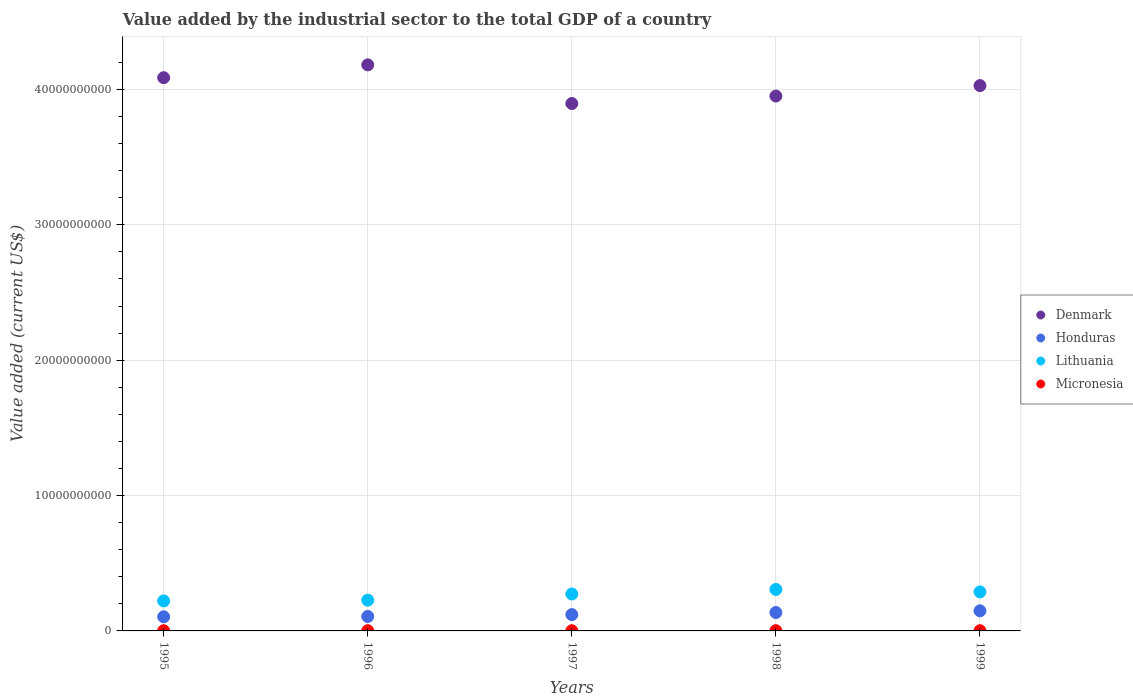How many different coloured dotlines are there?
Provide a short and direct response. 4. Is the number of dotlines equal to the number of legend labels?
Keep it short and to the point. Yes. What is the value added by the industrial sector to the total GDP in Micronesia in 1998?
Give a very brief answer. 1.81e+07. Across all years, what is the maximum value added by the industrial sector to the total GDP in Denmark?
Your response must be concise. 4.18e+1. Across all years, what is the minimum value added by the industrial sector to the total GDP in Honduras?
Your answer should be very brief. 1.04e+09. What is the total value added by the industrial sector to the total GDP in Micronesia in the graph?
Your answer should be compact. 8.26e+07. What is the difference between the value added by the industrial sector to the total GDP in Micronesia in 1996 and that in 1998?
Your response must be concise. -1.42e+06. What is the difference between the value added by the industrial sector to the total GDP in Denmark in 1997 and the value added by the industrial sector to the total GDP in Lithuania in 1999?
Ensure brevity in your answer.  3.61e+1. What is the average value added by the industrial sector to the total GDP in Micronesia per year?
Your answer should be compact. 1.65e+07. In the year 1995, what is the difference between the value added by the industrial sector to the total GDP in Honduras and value added by the industrial sector to the total GDP in Micronesia?
Ensure brevity in your answer.  1.03e+09. What is the ratio of the value added by the industrial sector to the total GDP in Micronesia in 1995 to that in 1997?
Your answer should be very brief. 1.05. What is the difference between the highest and the second highest value added by the industrial sector to the total GDP in Micronesia?
Keep it short and to the point. 5.22e+05. What is the difference between the highest and the lowest value added by the industrial sector to the total GDP in Denmark?
Your response must be concise. 2.86e+09. In how many years, is the value added by the industrial sector to the total GDP in Lithuania greater than the average value added by the industrial sector to the total GDP in Lithuania taken over all years?
Offer a terse response. 3. Is it the case that in every year, the sum of the value added by the industrial sector to the total GDP in Lithuania and value added by the industrial sector to the total GDP in Micronesia  is greater than the sum of value added by the industrial sector to the total GDP in Honduras and value added by the industrial sector to the total GDP in Denmark?
Provide a short and direct response. Yes. Does the value added by the industrial sector to the total GDP in Denmark monotonically increase over the years?
Offer a very short reply. No. Is the value added by the industrial sector to the total GDP in Denmark strictly greater than the value added by the industrial sector to the total GDP in Honduras over the years?
Offer a terse response. Yes. How many dotlines are there?
Provide a succinct answer. 4. What is the difference between two consecutive major ticks on the Y-axis?
Offer a very short reply. 1.00e+1. Does the graph contain grids?
Provide a short and direct response. Yes. What is the title of the graph?
Your response must be concise. Value added by the industrial sector to the total GDP of a country. What is the label or title of the Y-axis?
Offer a terse response. Value added (current US$). What is the Value added (current US$) of Denmark in 1995?
Your answer should be very brief. 4.09e+1. What is the Value added (current US$) of Honduras in 1995?
Provide a succinct answer. 1.04e+09. What is the Value added (current US$) of Lithuania in 1995?
Your answer should be very brief. 2.22e+09. What is the Value added (current US$) in Micronesia in 1995?
Ensure brevity in your answer.  1.55e+07. What is the Value added (current US$) of Denmark in 1996?
Provide a short and direct response. 4.18e+1. What is the Value added (current US$) in Honduras in 1996?
Ensure brevity in your answer.  1.07e+09. What is the Value added (current US$) of Lithuania in 1996?
Give a very brief answer. 2.27e+09. What is the Value added (current US$) in Micronesia in 1996?
Give a very brief answer. 1.67e+07. What is the Value added (current US$) in Denmark in 1997?
Offer a very short reply. 3.90e+1. What is the Value added (current US$) in Honduras in 1997?
Offer a very short reply. 1.21e+09. What is the Value added (current US$) of Lithuania in 1997?
Give a very brief answer. 2.73e+09. What is the Value added (current US$) of Micronesia in 1997?
Your response must be concise. 1.48e+07. What is the Value added (current US$) in Denmark in 1998?
Provide a short and direct response. 3.95e+1. What is the Value added (current US$) in Honduras in 1998?
Make the answer very short. 1.36e+09. What is the Value added (current US$) of Lithuania in 1998?
Provide a succinct answer. 3.06e+09. What is the Value added (current US$) in Micronesia in 1998?
Your answer should be very brief. 1.81e+07. What is the Value added (current US$) in Denmark in 1999?
Provide a succinct answer. 4.03e+1. What is the Value added (current US$) in Honduras in 1999?
Offer a very short reply. 1.49e+09. What is the Value added (current US$) in Lithuania in 1999?
Provide a short and direct response. 2.88e+09. What is the Value added (current US$) of Micronesia in 1999?
Provide a succinct answer. 1.76e+07. Across all years, what is the maximum Value added (current US$) of Denmark?
Ensure brevity in your answer.  4.18e+1. Across all years, what is the maximum Value added (current US$) of Honduras?
Offer a very short reply. 1.49e+09. Across all years, what is the maximum Value added (current US$) of Lithuania?
Keep it short and to the point. 3.06e+09. Across all years, what is the maximum Value added (current US$) in Micronesia?
Provide a short and direct response. 1.81e+07. Across all years, what is the minimum Value added (current US$) of Denmark?
Your answer should be compact. 3.90e+1. Across all years, what is the minimum Value added (current US$) in Honduras?
Provide a succinct answer. 1.04e+09. Across all years, what is the minimum Value added (current US$) in Lithuania?
Your answer should be very brief. 2.22e+09. Across all years, what is the minimum Value added (current US$) of Micronesia?
Your answer should be compact. 1.48e+07. What is the total Value added (current US$) of Denmark in the graph?
Give a very brief answer. 2.01e+11. What is the total Value added (current US$) in Honduras in the graph?
Keep it short and to the point. 6.17e+09. What is the total Value added (current US$) of Lithuania in the graph?
Your response must be concise. 1.32e+1. What is the total Value added (current US$) in Micronesia in the graph?
Your response must be concise. 8.26e+07. What is the difference between the Value added (current US$) in Denmark in 1995 and that in 1996?
Provide a succinct answer. -9.47e+08. What is the difference between the Value added (current US$) in Honduras in 1995 and that in 1996?
Your answer should be very brief. -2.47e+07. What is the difference between the Value added (current US$) of Lithuania in 1995 and that in 1996?
Your response must be concise. -5.62e+07. What is the difference between the Value added (current US$) of Micronesia in 1995 and that in 1996?
Your answer should be compact. -1.19e+06. What is the difference between the Value added (current US$) in Denmark in 1995 and that in 1997?
Your response must be concise. 1.91e+09. What is the difference between the Value added (current US$) in Honduras in 1995 and that in 1997?
Your answer should be very brief. -1.62e+08. What is the difference between the Value added (current US$) in Lithuania in 1995 and that in 1997?
Your answer should be very brief. -5.12e+08. What is the difference between the Value added (current US$) in Micronesia in 1995 and that in 1997?
Ensure brevity in your answer.  7.13e+05. What is the difference between the Value added (current US$) in Denmark in 1995 and that in 1998?
Give a very brief answer. 1.36e+09. What is the difference between the Value added (current US$) of Honduras in 1995 and that in 1998?
Provide a succinct answer. -3.16e+08. What is the difference between the Value added (current US$) of Lithuania in 1995 and that in 1998?
Your answer should be compact. -8.48e+08. What is the difference between the Value added (current US$) in Micronesia in 1995 and that in 1998?
Your response must be concise. -2.61e+06. What is the difference between the Value added (current US$) in Denmark in 1995 and that in 1999?
Keep it short and to the point. 5.84e+08. What is the difference between the Value added (current US$) of Honduras in 1995 and that in 1999?
Ensure brevity in your answer.  -4.41e+08. What is the difference between the Value added (current US$) of Lithuania in 1995 and that in 1999?
Your answer should be very brief. -6.67e+08. What is the difference between the Value added (current US$) of Micronesia in 1995 and that in 1999?
Offer a very short reply. -2.09e+06. What is the difference between the Value added (current US$) of Denmark in 1996 and that in 1997?
Offer a terse response. 2.86e+09. What is the difference between the Value added (current US$) in Honduras in 1996 and that in 1997?
Provide a short and direct response. -1.37e+08. What is the difference between the Value added (current US$) in Lithuania in 1996 and that in 1997?
Ensure brevity in your answer.  -4.55e+08. What is the difference between the Value added (current US$) of Micronesia in 1996 and that in 1997?
Give a very brief answer. 1.91e+06. What is the difference between the Value added (current US$) in Denmark in 1996 and that in 1998?
Give a very brief answer. 2.30e+09. What is the difference between the Value added (current US$) in Honduras in 1996 and that in 1998?
Offer a very short reply. -2.92e+08. What is the difference between the Value added (current US$) in Lithuania in 1996 and that in 1998?
Ensure brevity in your answer.  -7.92e+08. What is the difference between the Value added (current US$) in Micronesia in 1996 and that in 1998?
Your answer should be compact. -1.42e+06. What is the difference between the Value added (current US$) of Denmark in 1996 and that in 1999?
Offer a terse response. 1.53e+09. What is the difference between the Value added (current US$) in Honduras in 1996 and that in 1999?
Your response must be concise. -4.16e+08. What is the difference between the Value added (current US$) in Lithuania in 1996 and that in 1999?
Your answer should be very brief. -6.11e+08. What is the difference between the Value added (current US$) in Micronesia in 1996 and that in 1999?
Give a very brief answer. -8.94e+05. What is the difference between the Value added (current US$) in Denmark in 1997 and that in 1998?
Ensure brevity in your answer.  -5.51e+08. What is the difference between the Value added (current US$) in Honduras in 1997 and that in 1998?
Give a very brief answer. -1.54e+08. What is the difference between the Value added (current US$) in Lithuania in 1997 and that in 1998?
Provide a short and direct response. -3.36e+08. What is the difference between the Value added (current US$) in Micronesia in 1997 and that in 1998?
Give a very brief answer. -3.32e+06. What is the difference between the Value added (current US$) of Denmark in 1997 and that in 1999?
Provide a short and direct response. -1.32e+09. What is the difference between the Value added (current US$) in Honduras in 1997 and that in 1999?
Provide a short and direct response. -2.79e+08. What is the difference between the Value added (current US$) of Lithuania in 1997 and that in 1999?
Keep it short and to the point. -1.55e+08. What is the difference between the Value added (current US$) of Micronesia in 1997 and that in 1999?
Keep it short and to the point. -2.80e+06. What is the difference between the Value added (current US$) of Denmark in 1998 and that in 1999?
Offer a terse response. -7.73e+08. What is the difference between the Value added (current US$) in Honduras in 1998 and that in 1999?
Your response must be concise. -1.24e+08. What is the difference between the Value added (current US$) in Lithuania in 1998 and that in 1999?
Offer a very short reply. 1.81e+08. What is the difference between the Value added (current US$) in Micronesia in 1998 and that in 1999?
Make the answer very short. 5.22e+05. What is the difference between the Value added (current US$) of Denmark in 1995 and the Value added (current US$) of Honduras in 1996?
Your answer should be very brief. 3.98e+1. What is the difference between the Value added (current US$) of Denmark in 1995 and the Value added (current US$) of Lithuania in 1996?
Provide a succinct answer. 3.86e+1. What is the difference between the Value added (current US$) of Denmark in 1995 and the Value added (current US$) of Micronesia in 1996?
Offer a terse response. 4.09e+1. What is the difference between the Value added (current US$) of Honduras in 1995 and the Value added (current US$) of Lithuania in 1996?
Your answer should be very brief. -1.23e+09. What is the difference between the Value added (current US$) in Honduras in 1995 and the Value added (current US$) in Micronesia in 1996?
Make the answer very short. 1.03e+09. What is the difference between the Value added (current US$) in Lithuania in 1995 and the Value added (current US$) in Micronesia in 1996?
Keep it short and to the point. 2.20e+09. What is the difference between the Value added (current US$) of Denmark in 1995 and the Value added (current US$) of Honduras in 1997?
Your response must be concise. 3.97e+1. What is the difference between the Value added (current US$) of Denmark in 1995 and the Value added (current US$) of Lithuania in 1997?
Offer a very short reply. 3.81e+1. What is the difference between the Value added (current US$) in Denmark in 1995 and the Value added (current US$) in Micronesia in 1997?
Provide a succinct answer. 4.09e+1. What is the difference between the Value added (current US$) of Honduras in 1995 and the Value added (current US$) of Lithuania in 1997?
Your answer should be very brief. -1.68e+09. What is the difference between the Value added (current US$) in Honduras in 1995 and the Value added (current US$) in Micronesia in 1997?
Offer a very short reply. 1.03e+09. What is the difference between the Value added (current US$) of Lithuania in 1995 and the Value added (current US$) of Micronesia in 1997?
Your response must be concise. 2.20e+09. What is the difference between the Value added (current US$) in Denmark in 1995 and the Value added (current US$) in Honduras in 1998?
Provide a short and direct response. 3.95e+1. What is the difference between the Value added (current US$) of Denmark in 1995 and the Value added (current US$) of Lithuania in 1998?
Give a very brief answer. 3.78e+1. What is the difference between the Value added (current US$) of Denmark in 1995 and the Value added (current US$) of Micronesia in 1998?
Provide a succinct answer. 4.09e+1. What is the difference between the Value added (current US$) of Honduras in 1995 and the Value added (current US$) of Lithuania in 1998?
Ensure brevity in your answer.  -2.02e+09. What is the difference between the Value added (current US$) in Honduras in 1995 and the Value added (current US$) in Micronesia in 1998?
Your answer should be compact. 1.03e+09. What is the difference between the Value added (current US$) in Lithuania in 1995 and the Value added (current US$) in Micronesia in 1998?
Your response must be concise. 2.20e+09. What is the difference between the Value added (current US$) of Denmark in 1995 and the Value added (current US$) of Honduras in 1999?
Make the answer very short. 3.94e+1. What is the difference between the Value added (current US$) of Denmark in 1995 and the Value added (current US$) of Lithuania in 1999?
Provide a short and direct response. 3.80e+1. What is the difference between the Value added (current US$) of Denmark in 1995 and the Value added (current US$) of Micronesia in 1999?
Keep it short and to the point. 4.09e+1. What is the difference between the Value added (current US$) of Honduras in 1995 and the Value added (current US$) of Lithuania in 1999?
Keep it short and to the point. -1.84e+09. What is the difference between the Value added (current US$) of Honduras in 1995 and the Value added (current US$) of Micronesia in 1999?
Offer a very short reply. 1.03e+09. What is the difference between the Value added (current US$) of Lithuania in 1995 and the Value added (current US$) of Micronesia in 1999?
Ensure brevity in your answer.  2.20e+09. What is the difference between the Value added (current US$) of Denmark in 1996 and the Value added (current US$) of Honduras in 1997?
Offer a very short reply. 4.06e+1. What is the difference between the Value added (current US$) of Denmark in 1996 and the Value added (current US$) of Lithuania in 1997?
Ensure brevity in your answer.  3.91e+1. What is the difference between the Value added (current US$) of Denmark in 1996 and the Value added (current US$) of Micronesia in 1997?
Your response must be concise. 4.18e+1. What is the difference between the Value added (current US$) in Honduras in 1996 and the Value added (current US$) in Lithuania in 1997?
Your response must be concise. -1.66e+09. What is the difference between the Value added (current US$) in Honduras in 1996 and the Value added (current US$) in Micronesia in 1997?
Give a very brief answer. 1.05e+09. What is the difference between the Value added (current US$) in Lithuania in 1996 and the Value added (current US$) in Micronesia in 1997?
Your answer should be compact. 2.26e+09. What is the difference between the Value added (current US$) of Denmark in 1996 and the Value added (current US$) of Honduras in 1998?
Provide a succinct answer. 4.05e+1. What is the difference between the Value added (current US$) of Denmark in 1996 and the Value added (current US$) of Lithuania in 1998?
Offer a terse response. 3.88e+1. What is the difference between the Value added (current US$) in Denmark in 1996 and the Value added (current US$) in Micronesia in 1998?
Provide a short and direct response. 4.18e+1. What is the difference between the Value added (current US$) in Honduras in 1996 and the Value added (current US$) in Lithuania in 1998?
Your answer should be very brief. -1.99e+09. What is the difference between the Value added (current US$) in Honduras in 1996 and the Value added (current US$) in Micronesia in 1998?
Give a very brief answer. 1.05e+09. What is the difference between the Value added (current US$) of Lithuania in 1996 and the Value added (current US$) of Micronesia in 1998?
Your answer should be compact. 2.25e+09. What is the difference between the Value added (current US$) in Denmark in 1996 and the Value added (current US$) in Honduras in 1999?
Your response must be concise. 4.03e+1. What is the difference between the Value added (current US$) of Denmark in 1996 and the Value added (current US$) of Lithuania in 1999?
Provide a succinct answer. 3.89e+1. What is the difference between the Value added (current US$) in Denmark in 1996 and the Value added (current US$) in Micronesia in 1999?
Your response must be concise. 4.18e+1. What is the difference between the Value added (current US$) of Honduras in 1996 and the Value added (current US$) of Lithuania in 1999?
Your response must be concise. -1.81e+09. What is the difference between the Value added (current US$) of Honduras in 1996 and the Value added (current US$) of Micronesia in 1999?
Ensure brevity in your answer.  1.05e+09. What is the difference between the Value added (current US$) in Lithuania in 1996 and the Value added (current US$) in Micronesia in 1999?
Your answer should be compact. 2.25e+09. What is the difference between the Value added (current US$) of Denmark in 1997 and the Value added (current US$) of Honduras in 1998?
Your answer should be compact. 3.76e+1. What is the difference between the Value added (current US$) of Denmark in 1997 and the Value added (current US$) of Lithuania in 1998?
Keep it short and to the point. 3.59e+1. What is the difference between the Value added (current US$) of Denmark in 1997 and the Value added (current US$) of Micronesia in 1998?
Provide a short and direct response. 3.89e+1. What is the difference between the Value added (current US$) of Honduras in 1997 and the Value added (current US$) of Lithuania in 1998?
Offer a terse response. -1.86e+09. What is the difference between the Value added (current US$) of Honduras in 1997 and the Value added (current US$) of Micronesia in 1998?
Your answer should be compact. 1.19e+09. What is the difference between the Value added (current US$) in Lithuania in 1997 and the Value added (current US$) in Micronesia in 1998?
Give a very brief answer. 2.71e+09. What is the difference between the Value added (current US$) in Denmark in 1997 and the Value added (current US$) in Honduras in 1999?
Offer a very short reply. 3.75e+1. What is the difference between the Value added (current US$) of Denmark in 1997 and the Value added (current US$) of Lithuania in 1999?
Make the answer very short. 3.61e+1. What is the difference between the Value added (current US$) in Denmark in 1997 and the Value added (current US$) in Micronesia in 1999?
Your response must be concise. 3.89e+1. What is the difference between the Value added (current US$) of Honduras in 1997 and the Value added (current US$) of Lithuania in 1999?
Give a very brief answer. -1.68e+09. What is the difference between the Value added (current US$) in Honduras in 1997 and the Value added (current US$) in Micronesia in 1999?
Keep it short and to the point. 1.19e+09. What is the difference between the Value added (current US$) in Lithuania in 1997 and the Value added (current US$) in Micronesia in 1999?
Keep it short and to the point. 2.71e+09. What is the difference between the Value added (current US$) in Denmark in 1998 and the Value added (current US$) in Honduras in 1999?
Your answer should be very brief. 3.80e+1. What is the difference between the Value added (current US$) in Denmark in 1998 and the Value added (current US$) in Lithuania in 1999?
Make the answer very short. 3.66e+1. What is the difference between the Value added (current US$) in Denmark in 1998 and the Value added (current US$) in Micronesia in 1999?
Your answer should be very brief. 3.95e+1. What is the difference between the Value added (current US$) in Honduras in 1998 and the Value added (current US$) in Lithuania in 1999?
Offer a very short reply. -1.52e+09. What is the difference between the Value added (current US$) of Honduras in 1998 and the Value added (current US$) of Micronesia in 1999?
Make the answer very short. 1.34e+09. What is the difference between the Value added (current US$) in Lithuania in 1998 and the Value added (current US$) in Micronesia in 1999?
Your answer should be compact. 3.05e+09. What is the average Value added (current US$) in Denmark per year?
Provide a succinct answer. 4.03e+1. What is the average Value added (current US$) of Honduras per year?
Provide a short and direct response. 1.23e+09. What is the average Value added (current US$) in Lithuania per year?
Provide a succinct answer. 2.63e+09. What is the average Value added (current US$) in Micronesia per year?
Your answer should be compact. 1.65e+07. In the year 1995, what is the difference between the Value added (current US$) of Denmark and Value added (current US$) of Honduras?
Provide a short and direct response. 3.98e+1. In the year 1995, what is the difference between the Value added (current US$) of Denmark and Value added (current US$) of Lithuania?
Give a very brief answer. 3.87e+1. In the year 1995, what is the difference between the Value added (current US$) in Denmark and Value added (current US$) in Micronesia?
Give a very brief answer. 4.09e+1. In the year 1995, what is the difference between the Value added (current US$) of Honduras and Value added (current US$) of Lithuania?
Provide a succinct answer. -1.17e+09. In the year 1995, what is the difference between the Value added (current US$) in Honduras and Value added (current US$) in Micronesia?
Provide a short and direct response. 1.03e+09. In the year 1995, what is the difference between the Value added (current US$) of Lithuania and Value added (current US$) of Micronesia?
Ensure brevity in your answer.  2.20e+09. In the year 1996, what is the difference between the Value added (current US$) in Denmark and Value added (current US$) in Honduras?
Make the answer very short. 4.08e+1. In the year 1996, what is the difference between the Value added (current US$) in Denmark and Value added (current US$) in Lithuania?
Your answer should be very brief. 3.95e+1. In the year 1996, what is the difference between the Value added (current US$) of Denmark and Value added (current US$) of Micronesia?
Offer a very short reply. 4.18e+1. In the year 1996, what is the difference between the Value added (current US$) in Honduras and Value added (current US$) in Lithuania?
Offer a very short reply. -1.20e+09. In the year 1996, what is the difference between the Value added (current US$) in Honduras and Value added (current US$) in Micronesia?
Your answer should be compact. 1.05e+09. In the year 1996, what is the difference between the Value added (current US$) in Lithuania and Value added (current US$) in Micronesia?
Your response must be concise. 2.26e+09. In the year 1997, what is the difference between the Value added (current US$) of Denmark and Value added (current US$) of Honduras?
Ensure brevity in your answer.  3.78e+1. In the year 1997, what is the difference between the Value added (current US$) in Denmark and Value added (current US$) in Lithuania?
Your response must be concise. 3.62e+1. In the year 1997, what is the difference between the Value added (current US$) in Denmark and Value added (current US$) in Micronesia?
Keep it short and to the point. 3.89e+1. In the year 1997, what is the difference between the Value added (current US$) of Honduras and Value added (current US$) of Lithuania?
Make the answer very short. -1.52e+09. In the year 1997, what is the difference between the Value added (current US$) in Honduras and Value added (current US$) in Micronesia?
Make the answer very short. 1.19e+09. In the year 1997, what is the difference between the Value added (current US$) in Lithuania and Value added (current US$) in Micronesia?
Your response must be concise. 2.71e+09. In the year 1998, what is the difference between the Value added (current US$) in Denmark and Value added (current US$) in Honduras?
Provide a succinct answer. 3.82e+1. In the year 1998, what is the difference between the Value added (current US$) of Denmark and Value added (current US$) of Lithuania?
Your answer should be very brief. 3.65e+1. In the year 1998, what is the difference between the Value added (current US$) in Denmark and Value added (current US$) in Micronesia?
Ensure brevity in your answer.  3.95e+1. In the year 1998, what is the difference between the Value added (current US$) in Honduras and Value added (current US$) in Lithuania?
Keep it short and to the point. -1.70e+09. In the year 1998, what is the difference between the Value added (current US$) of Honduras and Value added (current US$) of Micronesia?
Provide a succinct answer. 1.34e+09. In the year 1998, what is the difference between the Value added (current US$) in Lithuania and Value added (current US$) in Micronesia?
Ensure brevity in your answer.  3.05e+09. In the year 1999, what is the difference between the Value added (current US$) of Denmark and Value added (current US$) of Honduras?
Your response must be concise. 3.88e+1. In the year 1999, what is the difference between the Value added (current US$) in Denmark and Value added (current US$) in Lithuania?
Make the answer very short. 3.74e+1. In the year 1999, what is the difference between the Value added (current US$) of Denmark and Value added (current US$) of Micronesia?
Keep it short and to the point. 4.03e+1. In the year 1999, what is the difference between the Value added (current US$) of Honduras and Value added (current US$) of Lithuania?
Ensure brevity in your answer.  -1.40e+09. In the year 1999, what is the difference between the Value added (current US$) in Honduras and Value added (current US$) in Micronesia?
Ensure brevity in your answer.  1.47e+09. In the year 1999, what is the difference between the Value added (current US$) in Lithuania and Value added (current US$) in Micronesia?
Your response must be concise. 2.87e+09. What is the ratio of the Value added (current US$) in Denmark in 1995 to that in 1996?
Ensure brevity in your answer.  0.98. What is the ratio of the Value added (current US$) of Honduras in 1995 to that in 1996?
Your answer should be very brief. 0.98. What is the ratio of the Value added (current US$) of Lithuania in 1995 to that in 1996?
Your response must be concise. 0.98. What is the ratio of the Value added (current US$) in Micronesia in 1995 to that in 1996?
Your response must be concise. 0.93. What is the ratio of the Value added (current US$) of Denmark in 1995 to that in 1997?
Provide a succinct answer. 1.05. What is the ratio of the Value added (current US$) of Honduras in 1995 to that in 1997?
Keep it short and to the point. 0.87. What is the ratio of the Value added (current US$) in Lithuania in 1995 to that in 1997?
Make the answer very short. 0.81. What is the ratio of the Value added (current US$) in Micronesia in 1995 to that in 1997?
Offer a very short reply. 1.05. What is the ratio of the Value added (current US$) in Denmark in 1995 to that in 1998?
Your answer should be very brief. 1.03. What is the ratio of the Value added (current US$) of Honduras in 1995 to that in 1998?
Give a very brief answer. 0.77. What is the ratio of the Value added (current US$) in Lithuania in 1995 to that in 1998?
Provide a short and direct response. 0.72. What is the ratio of the Value added (current US$) in Micronesia in 1995 to that in 1998?
Ensure brevity in your answer.  0.86. What is the ratio of the Value added (current US$) of Denmark in 1995 to that in 1999?
Offer a terse response. 1.01. What is the ratio of the Value added (current US$) of Honduras in 1995 to that in 1999?
Make the answer very short. 0.7. What is the ratio of the Value added (current US$) in Lithuania in 1995 to that in 1999?
Your response must be concise. 0.77. What is the ratio of the Value added (current US$) of Micronesia in 1995 to that in 1999?
Give a very brief answer. 0.88. What is the ratio of the Value added (current US$) of Denmark in 1996 to that in 1997?
Give a very brief answer. 1.07. What is the ratio of the Value added (current US$) in Honduras in 1996 to that in 1997?
Keep it short and to the point. 0.89. What is the ratio of the Value added (current US$) in Lithuania in 1996 to that in 1997?
Ensure brevity in your answer.  0.83. What is the ratio of the Value added (current US$) in Micronesia in 1996 to that in 1997?
Make the answer very short. 1.13. What is the ratio of the Value added (current US$) of Denmark in 1996 to that in 1998?
Provide a succinct answer. 1.06. What is the ratio of the Value added (current US$) in Honduras in 1996 to that in 1998?
Provide a succinct answer. 0.79. What is the ratio of the Value added (current US$) in Lithuania in 1996 to that in 1998?
Keep it short and to the point. 0.74. What is the ratio of the Value added (current US$) in Micronesia in 1996 to that in 1998?
Offer a very short reply. 0.92. What is the ratio of the Value added (current US$) of Denmark in 1996 to that in 1999?
Ensure brevity in your answer.  1.04. What is the ratio of the Value added (current US$) in Honduras in 1996 to that in 1999?
Your answer should be compact. 0.72. What is the ratio of the Value added (current US$) in Lithuania in 1996 to that in 1999?
Your response must be concise. 0.79. What is the ratio of the Value added (current US$) of Micronesia in 1996 to that in 1999?
Offer a very short reply. 0.95. What is the ratio of the Value added (current US$) in Denmark in 1997 to that in 1998?
Your answer should be very brief. 0.99. What is the ratio of the Value added (current US$) in Honduras in 1997 to that in 1998?
Offer a very short reply. 0.89. What is the ratio of the Value added (current US$) of Lithuania in 1997 to that in 1998?
Ensure brevity in your answer.  0.89. What is the ratio of the Value added (current US$) of Micronesia in 1997 to that in 1998?
Keep it short and to the point. 0.82. What is the ratio of the Value added (current US$) of Denmark in 1997 to that in 1999?
Offer a terse response. 0.97. What is the ratio of the Value added (current US$) of Honduras in 1997 to that in 1999?
Provide a succinct answer. 0.81. What is the ratio of the Value added (current US$) in Lithuania in 1997 to that in 1999?
Make the answer very short. 0.95. What is the ratio of the Value added (current US$) of Micronesia in 1997 to that in 1999?
Give a very brief answer. 0.84. What is the ratio of the Value added (current US$) in Denmark in 1998 to that in 1999?
Your response must be concise. 0.98. What is the ratio of the Value added (current US$) of Honduras in 1998 to that in 1999?
Offer a terse response. 0.92. What is the ratio of the Value added (current US$) in Lithuania in 1998 to that in 1999?
Offer a terse response. 1.06. What is the ratio of the Value added (current US$) of Micronesia in 1998 to that in 1999?
Give a very brief answer. 1.03. What is the difference between the highest and the second highest Value added (current US$) of Denmark?
Ensure brevity in your answer.  9.47e+08. What is the difference between the highest and the second highest Value added (current US$) in Honduras?
Make the answer very short. 1.24e+08. What is the difference between the highest and the second highest Value added (current US$) in Lithuania?
Your response must be concise. 1.81e+08. What is the difference between the highest and the second highest Value added (current US$) in Micronesia?
Ensure brevity in your answer.  5.22e+05. What is the difference between the highest and the lowest Value added (current US$) in Denmark?
Keep it short and to the point. 2.86e+09. What is the difference between the highest and the lowest Value added (current US$) of Honduras?
Ensure brevity in your answer.  4.41e+08. What is the difference between the highest and the lowest Value added (current US$) in Lithuania?
Ensure brevity in your answer.  8.48e+08. What is the difference between the highest and the lowest Value added (current US$) in Micronesia?
Ensure brevity in your answer.  3.32e+06. 